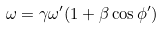<formula> <loc_0><loc_0><loc_500><loc_500>\omega = \gamma \omega ^ { \prime } ( 1 + \beta \cos \phi ^ { \prime } ) \\</formula> 